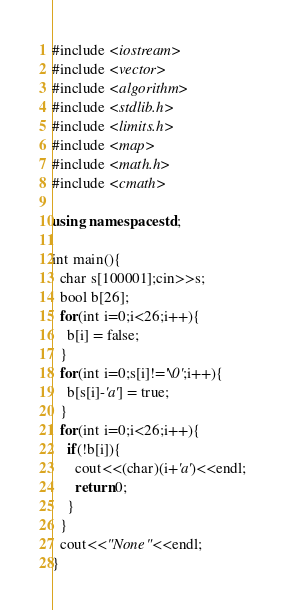Convert code to text. <code><loc_0><loc_0><loc_500><loc_500><_C++_>#include <iostream>
#include <vector>
#include <algorithm>
#include <stdlib.h>
#include <limits.h>
#include <map>
#include <math.h>
#include <cmath>

using namespace std;

int main(){
  char s[100001];cin>>s;
  bool b[26];
  for(int i=0;i<26;i++){
    b[i] = false;  
  }
  for(int i=0;s[i]!='\0';i++){
    b[s[i]-'a'] = true;
  }
  for(int i=0;i<26;i++){
    if(!b[i]){
      cout<<(char)(i+'a')<<endl;
      return 0;
    }
  }
  cout<<"None"<<endl;
}</code> 